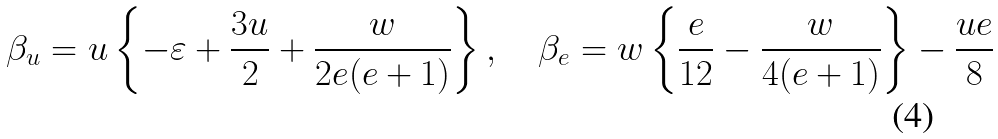Convert formula to latex. <formula><loc_0><loc_0><loc_500><loc_500>\beta _ { u } = u \left \{ - \varepsilon + \frac { 3 u } { 2 } + \frac { w } { 2 e ( e + 1 ) } \right \} , \quad \beta _ { e } = w \left \{ \frac { e } { 1 2 } - \frac { w } { 4 ( e + 1 ) } \right \} - \frac { u e } { 8 }</formula> 